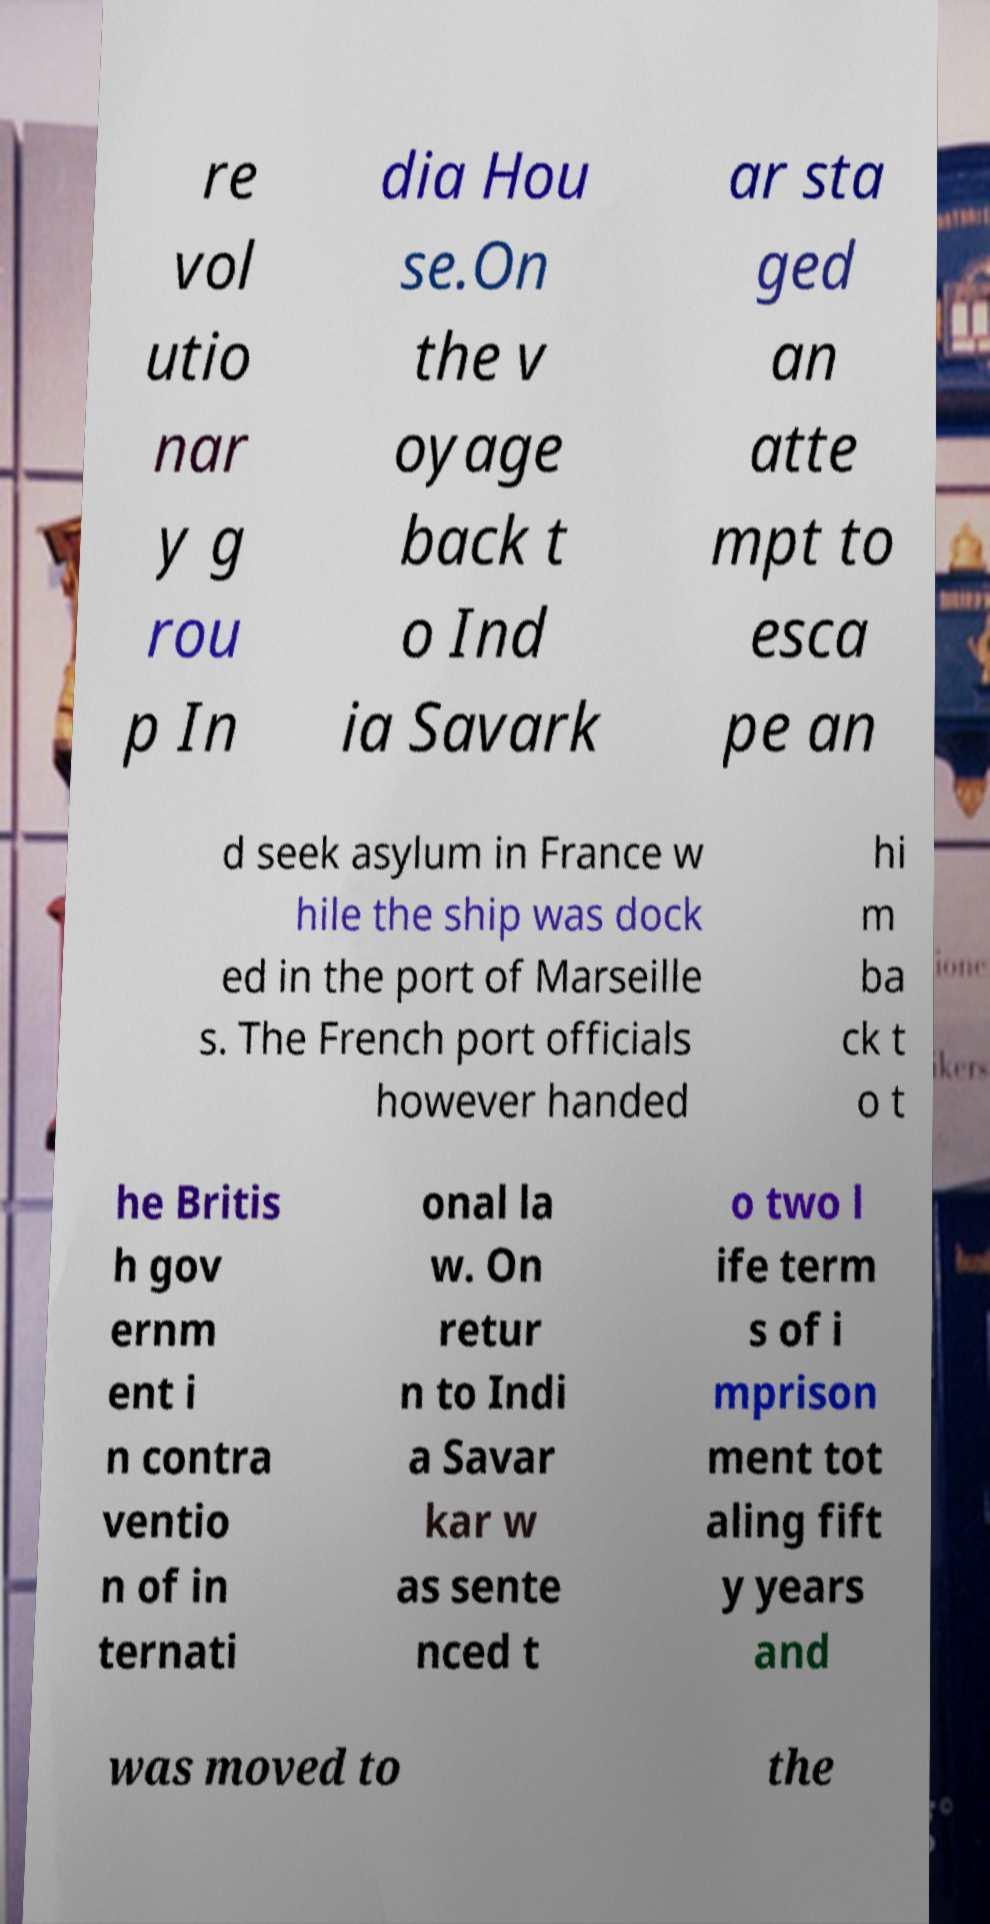Can you read and provide the text displayed in the image?This photo seems to have some interesting text. Can you extract and type it out for me? re vol utio nar y g rou p In dia Hou se.On the v oyage back t o Ind ia Savark ar sta ged an atte mpt to esca pe an d seek asylum in France w hile the ship was dock ed in the port of Marseille s. The French port officials however handed hi m ba ck t o t he Britis h gov ernm ent i n contra ventio n of in ternati onal la w. On retur n to Indi a Savar kar w as sente nced t o two l ife term s of i mprison ment tot aling fift y years and was moved to the 